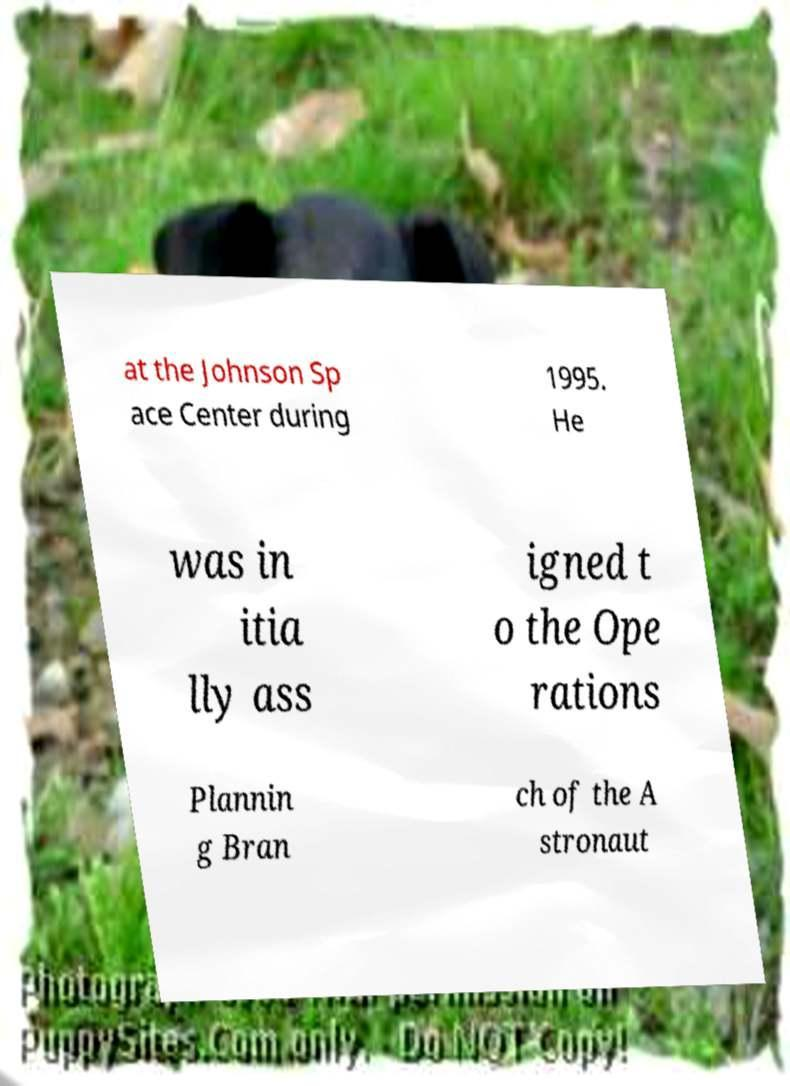Please read and relay the text visible in this image. What does it say? at the Johnson Sp ace Center during 1995. He was in itia lly ass igned t o the Ope rations Plannin g Bran ch of the A stronaut 